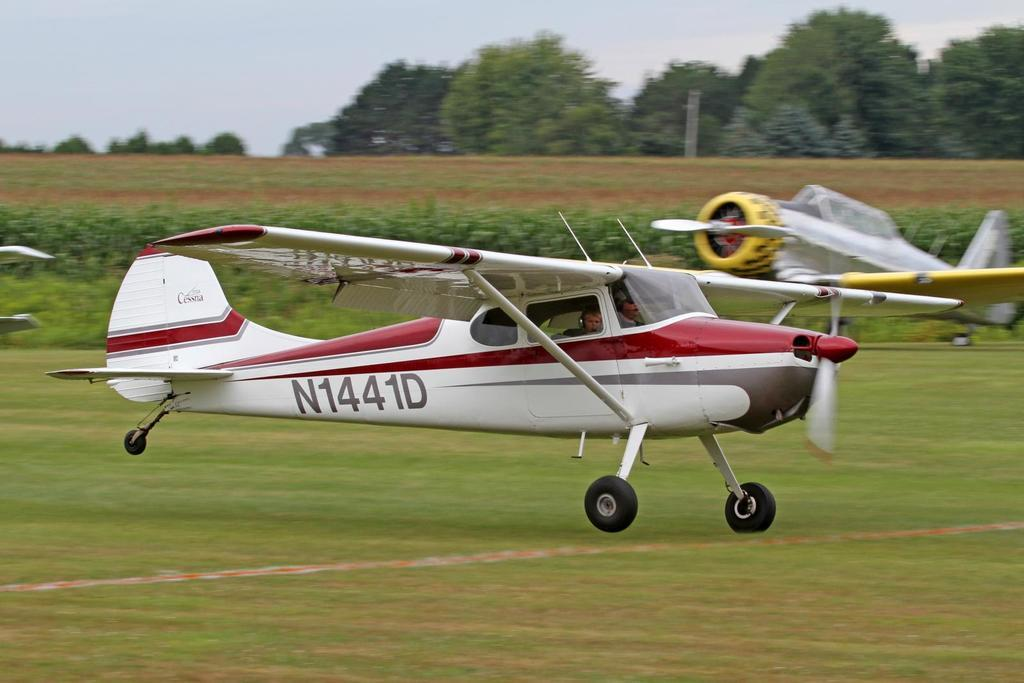What color is the aircraft in the image? The aircraft in the image is white. Can you describe the background of the image? The background of the image is slightly blurred. Are there any other aircraft visible in the image? Yes, another aircraft is visible in the background. What type of natural elements can be seen in the background? Plants and trees are visible in the background. How are the trees positioned in the image? The trees are visible in the sky in the background. What type of music can be heard playing in the background of the image? There is no music present in the image; it is a still photograph of an aircraft and its surroundings. 